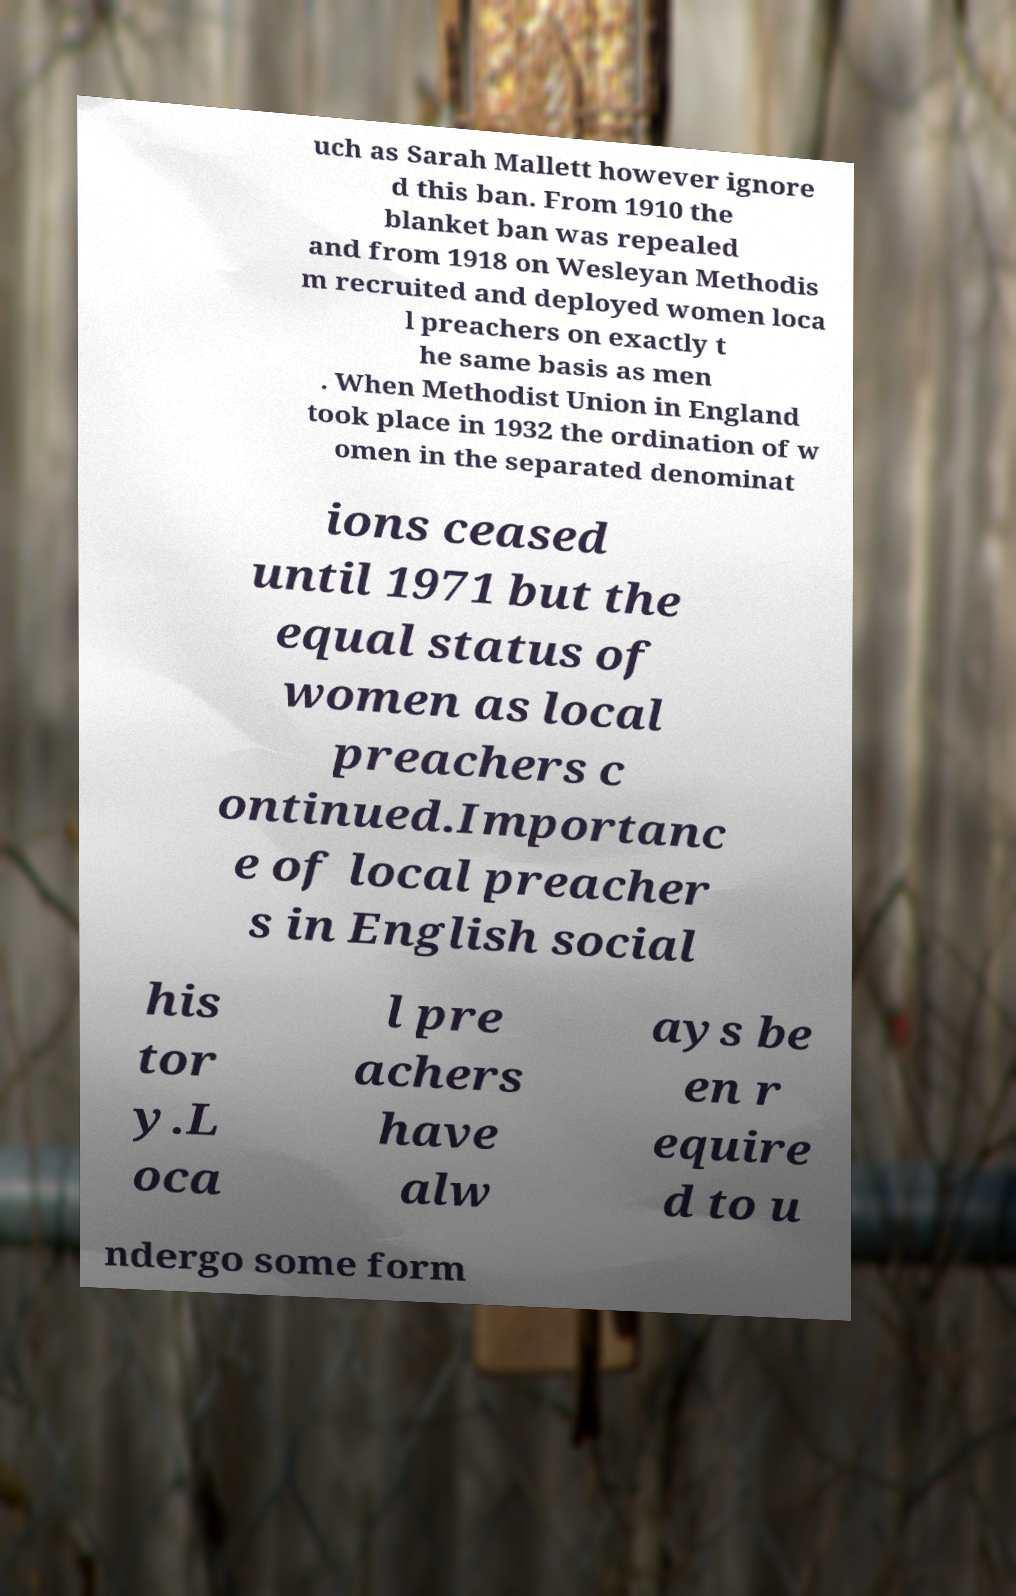There's text embedded in this image that I need extracted. Can you transcribe it verbatim? uch as Sarah Mallett however ignore d this ban. From 1910 the blanket ban was repealed and from 1918 on Wesleyan Methodis m recruited and deployed women loca l preachers on exactly t he same basis as men . When Methodist Union in England took place in 1932 the ordination of w omen in the separated denominat ions ceased until 1971 but the equal status of women as local preachers c ontinued.Importanc e of local preacher s in English social his tor y.L oca l pre achers have alw ays be en r equire d to u ndergo some form 